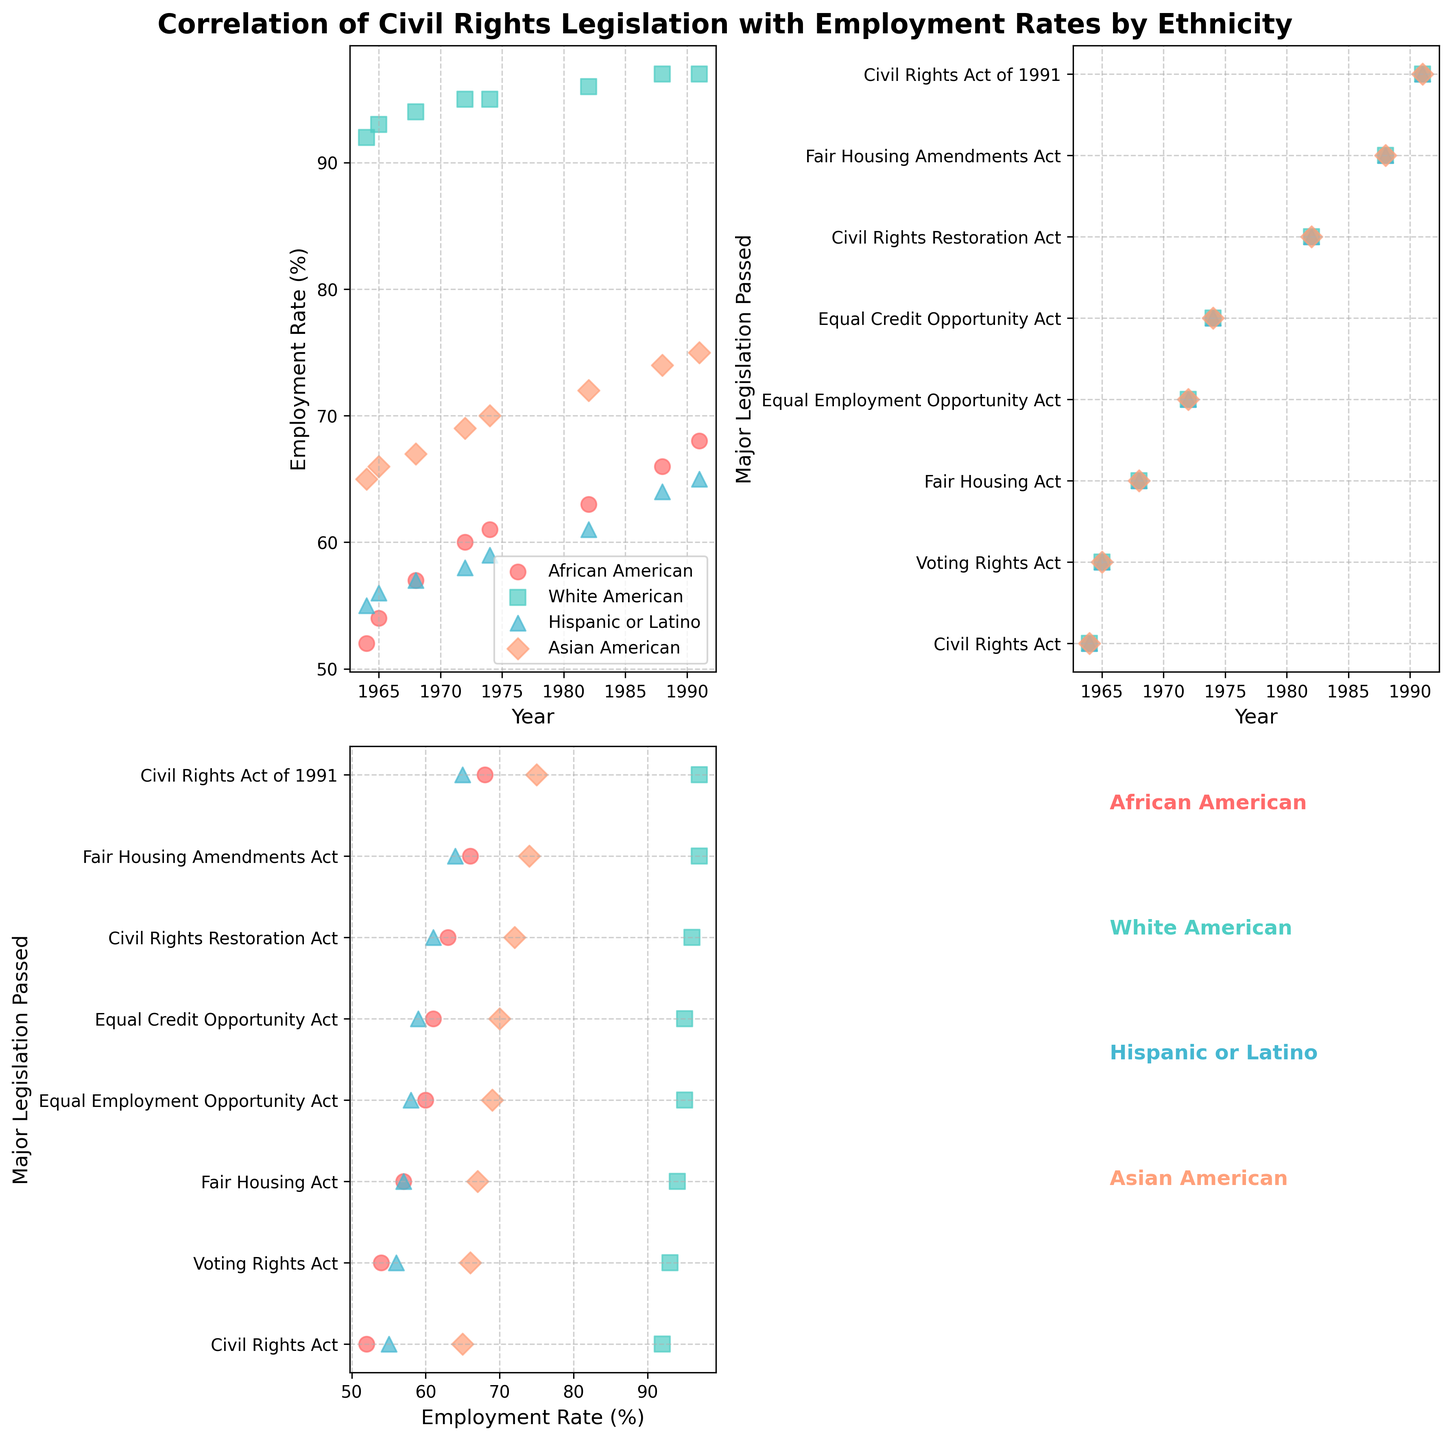What is the title of the figure? The title is located at the top center of the figure, which reads "Correlation of Civil Rights Legislation with Employment Rates by Ethnicity".
Answer: Correlation of Civil Rights Legislation with Employment Rates by Ethnicity Which axes compare Employment Rate with Year? The subplots that compare Employment Rate with Year are specifically the first subplot on the top-left. The x-axis is for Year and the y-axis is for Employment Rate (%).
Answer: The top-left plot How many ethnic groups are represented in the figure? The number of different ethnic groups can be determined by the number of unique legend entries or colors in the scatter plots. There are four, which are African American, White American, Hispanic or Latino, and Asian American.
Answer: Four Which ethnic group had the lowest Employment Rate in 1964? To find the lowest Employment Rate in 1964, look at the scatter points for the year 1964 in the top-left plot. The African American group has the lowest rate at 52%.
Answer: African American What was the Employment Rate for Asian Americans in 1982? Check the top-left subplot for the scatter points corresponding to Asian Americans in the year 1982. The Employment Rate for Asian Americans in 1982 is 72%.
Answer: 72% How does the Employment Rate of Hispanic or Latino in 1974 compare with African Americans in the same year? Look at the scatter points for both Hispanic or Latino and African American groups in the year 1974 on the top-left plot. The Employment Rate for Hispanic or Latino is 59%, while for African American it is 61%. Hispanic or Latino is slightly lower.
Answer: Hispanic or Latino is lower What trend is observed in the Employment Rates of White Americans from 1964 to 1991? Observing the scatter points for White Americans from 1964 to 1991 in the top-left plot, the Employment Rates show a slight upward trend, starting at 92% and peaking at 97%.
Answer: Slight upward trend Which year had major legislations according to the middle-right scatter plot, and how many such legislations are there? The middle-right plot shows Major Legislation Passed by Year. By counting the unique points on the y-axis, there are 8 major legislations detailed in the dataset.
Answer: 8 legislations What is the Employment Rate trend for African Americans before and after the Voting Rights Act of 1965? By looking at the Employment Rates for African Americans in the years surrounding 1965, before the year 1965 the rate is 52% in 1964, and 54% in 1965. After, in 1968 it is 57%, indicating an upward trend.
Answer: Upward trend Does the Employment Rate for Asian Americans change consistently with each major legislation passed? Observing the pattern of points for Asian Americans in the top-left and bottom-left plots, the Employment Rate for Asian Americans generally increases, but not necessarily with every single legislation passed, showing some fluctuations.
Answer: Generally increases with fluctuations 